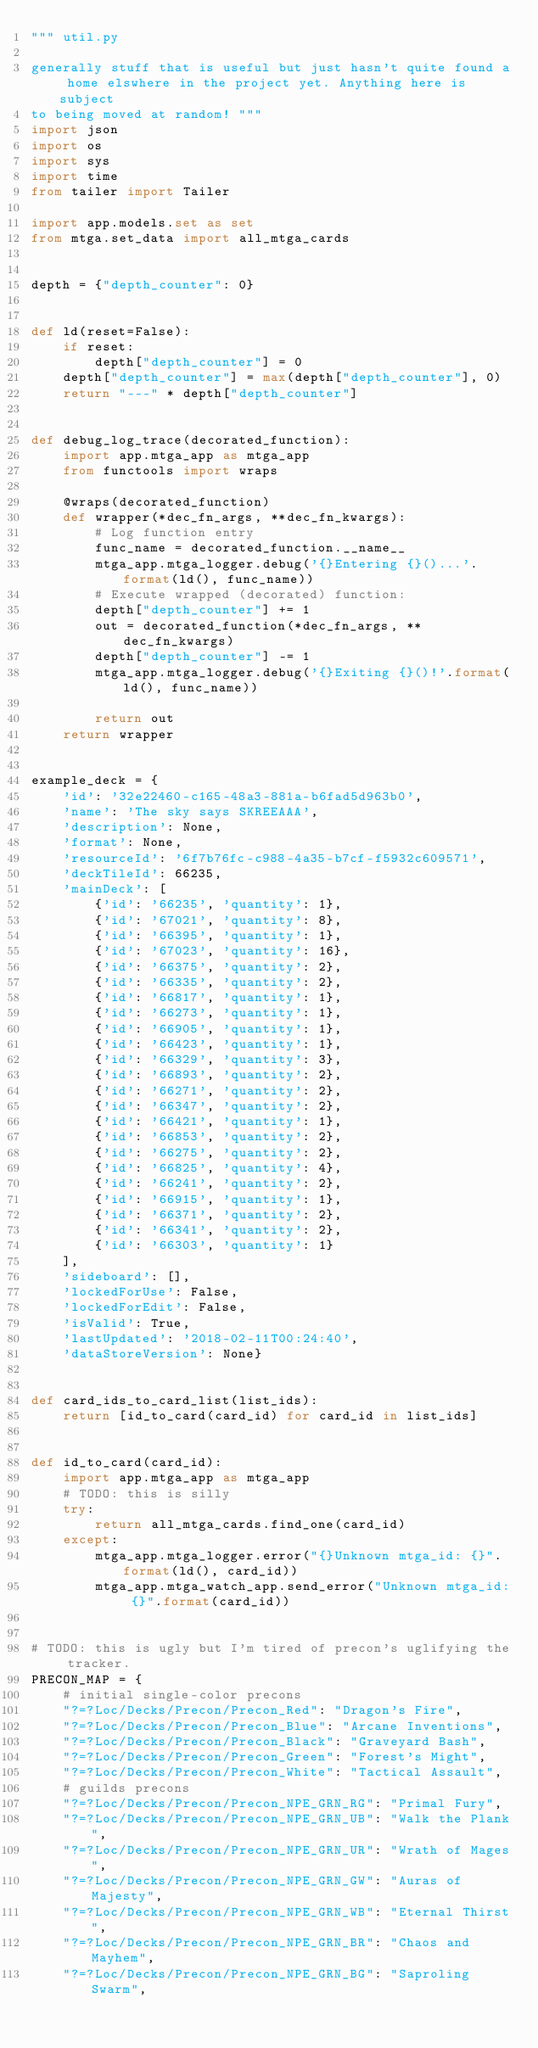<code> <loc_0><loc_0><loc_500><loc_500><_Python_>""" util.py

generally stuff that is useful but just hasn't quite found a home elswhere in the project yet. Anything here is subject
to being moved at random! """
import json
import os
import sys
import time
from tailer import Tailer

import app.models.set as set
from mtga.set_data import all_mtga_cards


depth = {"depth_counter": 0}


def ld(reset=False):
    if reset:
        depth["depth_counter"] = 0
    depth["depth_counter"] = max(depth["depth_counter"], 0)
    return "---" * depth["depth_counter"]


def debug_log_trace(decorated_function):
    import app.mtga_app as mtga_app
    from functools import wraps

    @wraps(decorated_function)
    def wrapper(*dec_fn_args, **dec_fn_kwargs):
        # Log function entry
        func_name = decorated_function.__name__
        mtga_app.mtga_logger.debug('{}Entering {}()...'.format(ld(), func_name))
        # Execute wrapped (decorated) function:
        depth["depth_counter"] += 1
        out = decorated_function(*dec_fn_args, **dec_fn_kwargs)
        depth["depth_counter"] -= 1
        mtga_app.mtga_logger.debug('{}Exiting {}()!'.format(ld(), func_name))

        return out
    return wrapper


example_deck = {
    'id': '32e22460-c165-48a3-881a-b6fad5d963b0',
    'name': 'The sky says SKREEAAA',
    'description': None,
    'format': None,
    'resourceId': '6f7b76fc-c988-4a35-b7cf-f5932c609571',
    'deckTileId': 66235,
    'mainDeck': [
        {'id': '66235', 'quantity': 1},
        {'id': '67021', 'quantity': 8},
        {'id': '66395', 'quantity': 1},
        {'id': '67023', 'quantity': 16},
        {'id': '66375', 'quantity': 2},
        {'id': '66335', 'quantity': 2},
        {'id': '66817', 'quantity': 1},
        {'id': '66273', 'quantity': 1},
        {'id': '66905', 'quantity': 1},
        {'id': '66423', 'quantity': 1},
        {'id': '66329', 'quantity': 3},
        {'id': '66893', 'quantity': 2},
        {'id': '66271', 'quantity': 2},
        {'id': '66347', 'quantity': 2},
        {'id': '66421', 'quantity': 1},
        {'id': '66853', 'quantity': 2},
        {'id': '66275', 'quantity': 2},
        {'id': '66825', 'quantity': 4},
        {'id': '66241', 'quantity': 2},
        {'id': '66915', 'quantity': 1},
        {'id': '66371', 'quantity': 2},
        {'id': '66341', 'quantity': 2},
        {'id': '66303', 'quantity': 1}
    ],
    'sideboard': [],
    'lockedForUse': False,
    'lockedForEdit': False,
    'isValid': True,
    'lastUpdated': '2018-02-11T00:24:40',
    'dataStoreVersion': None}


def card_ids_to_card_list(list_ids):
    return [id_to_card(card_id) for card_id in list_ids]


def id_to_card(card_id):
    import app.mtga_app as mtga_app
    # TODO: this is silly
    try:
        return all_mtga_cards.find_one(card_id)
    except:
        mtga_app.mtga_logger.error("{}Unknown mtga_id: {}".format(ld(), card_id))
        mtga_app.mtga_watch_app.send_error("Unknown mtga_id: {}".format(card_id))


# TODO: this is ugly but I'm tired of precon's uglifying the tracker.
PRECON_MAP = {
    # initial single-color precons
    "?=?Loc/Decks/Precon/Precon_Red": "Dragon's Fire",
    "?=?Loc/Decks/Precon/Precon_Blue": "Arcane Inventions",
    "?=?Loc/Decks/Precon/Precon_Black": "Graveyard Bash",
    "?=?Loc/Decks/Precon/Precon_Green": "Forest's Might",
    "?=?Loc/Decks/Precon/Precon_White": "Tactical Assault",
    # guilds precons
    "?=?Loc/Decks/Precon/Precon_NPE_GRN_RG": "Primal Fury",
    "?=?Loc/Decks/Precon/Precon_NPE_GRN_UB": "Walk the Plank",
    "?=?Loc/Decks/Precon/Precon_NPE_GRN_UR": "Wrath of Mages",
    "?=?Loc/Decks/Precon/Precon_NPE_GRN_GW": "Auras of Majesty",
    "?=?Loc/Decks/Precon/Precon_NPE_GRN_WB": "Eternal Thirst",
    "?=?Loc/Decks/Precon/Precon_NPE_GRN_BR": "Chaos and Mayhem",
    "?=?Loc/Decks/Precon/Precon_NPE_GRN_BG": "Saproling Swarm",</code> 